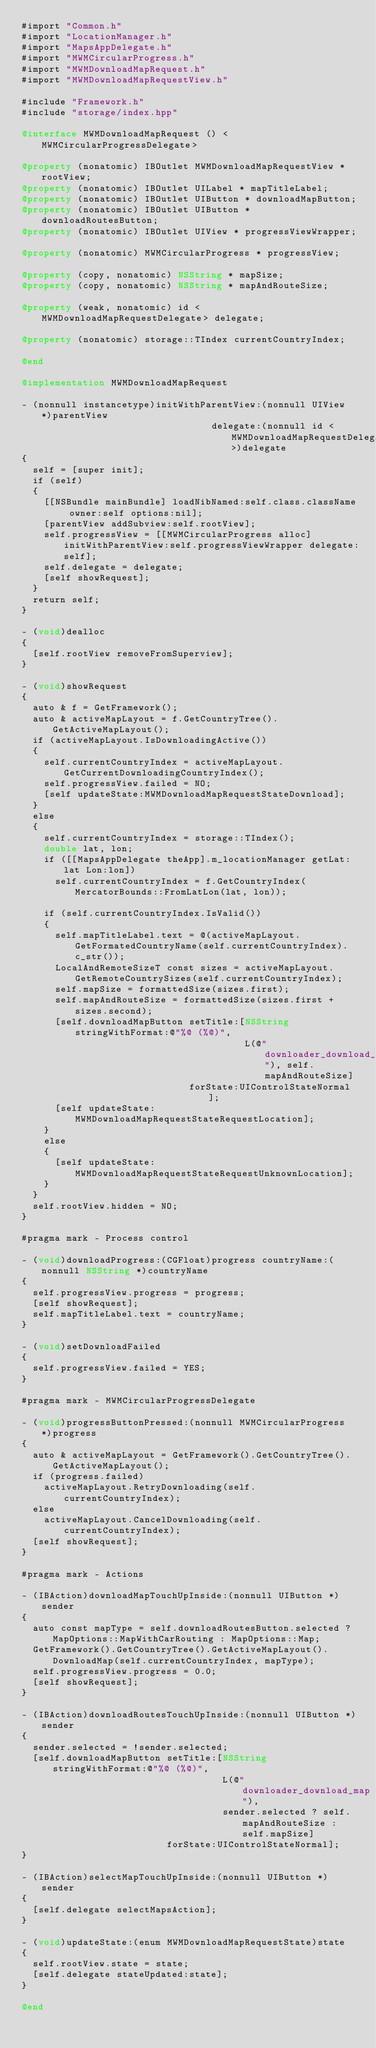<code> <loc_0><loc_0><loc_500><loc_500><_ObjectiveC_>#import "Common.h"
#import "LocationManager.h"
#import "MapsAppDelegate.h"
#import "MWMCircularProgress.h"
#import "MWMDownloadMapRequest.h"
#import "MWMDownloadMapRequestView.h"

#include "Framework.h"
#include "storage/index.hpp"

@interface MWMDownloadMapRequest () <MWMCircularProgressDelegate>

@property (nonatomic) IBOutlet MWMDownloadMapRequestView * rootView;
@property (nonatomic) IBOutlet UILabel * mapTitleLabel;
@property (nonatomic) IBOutlet UIButton * downloadMapButton;
@property (nonatomic) IBOutlet UIButton * downloadRoutesButton;
@property (nonatomic) IBOutlet UIView * progressViewWrapper;

@property (nonatomic) MWMCircularProgress * progressView;

@property (copy, nonatomic) NSString * mapSize;
@property (copy, nonatomic) NSString * mapAndRouteSize;

@property (weak, nonatomic) id <MWMDownloadMapRequestDelegate> delegate;

@property (nonatomic) storage::TIndex currentCountryIndex;

@end

@implementation MWMDownloadMapRequest

- (nonnull instancetype)initWithParentView:(nonnull UIView *)parentView
                                  delegate:(nonnull id <MWMDownloadMapRequestDelegate>)delegate
{
  self = [super init];
  if (self)
  {
    [[NSBundle mainBundle] loadNibNamed:self.class.className owner:self options:nil];
    [parentView addSubview:self.rootView];
    self.progressView = [[MWMCircularProgress alloc] initWithParentView:self.progressViewWrapper delegate:self];
    self.delegate = delegate;
    [self showRequest];
  }
  return self;
}

- (void)dealloc
{
  [self.rootView removeFromSuperview];
}

- (void)showRequest
{
  auto & f = GetFramework();
  auto & activeMapLayout = f.GetCountryTree().GetActiveMapLayout();
  if (activeMapLayout.IsDownloadingActive())
  {
    self.currentCountryIndex = activeMapLayout.GetCurrentDownloadingCountryIndex();
    self.progressView.failed = NO;
    [self updateState:MWMDownloadMapRequestStateDownload];
  }
  else
  {
    self.currentCountryIndex = storage::TIndex();
    double lat, lon;
    if ([[MapsAppDelegate theApp].m_locationManager getLat:lat Lon:lon])
      self.currentCountryIndex = f.GetCountryIndex(MercatorBounds::FromLatLon(lat, lon));

    if (self.currentCountryIndex.IsValid())
    {
      self.mapTitleLabel.text = @(activeMapLayout.GetFormatedCountryName(self.currentCountryIndex).c_str());
      LocalAndRemoteSizeT const sizes = activeMapLayout.GetRemoteCountrySizes(self.currentCountryIndex);
      self.mapSize = formattedSize(sizes.first);
      self.mapAndRouteSize = formattedSize(sizes.first + sizes.second);
      [self.downloadMapButton setTitle:[NSString stringWithFormat:@"%@ (%@)",
                                        L(@"downloader_download_map"), self.mapAndRouteSize]
                              forState:UIControlStateNormal];
      [self updateState:MWMDownloadMapRequestStateRequestLocation];
    }
    else
    {
      [self updateState:MWMDownloadMapRequestStateRequestUnknownLocation];
    }
  }
  self.rootView.hidden = NO;
}

#pragma mark - Process control

- (void)downloadProgress:(CGFloat)progress countryName:(nonnull NSString *)countryName
{
  self.progressView.progress = progress;
  [self showRequest];
  self.mapTitleLabel.text = countryName;
}

- (void)setDownloadFailed
{
  self.progressView.failed = YES;
}

#pragma mark - MWMCircularProgressDelegate

- (void)progressButtonPressed:(nonnull MWMCircularProgress *)progress
{
  auto & activeMapLayout = GetFramework().GetCountryTree().GetActiveMapLayout();
  if (progress.failed)
    activeMapLayout.RetryDownloading(self.currentCountryIndex);
  else
    activeMapLayout.CancelDownloading(self.currentCountryIndex);
  [self showRequest];
}

#pragma mark - Actions

- (IBAction)downloadMapTouchUpInside:(nonnull UIButton *)sender
{
  auto const mapType = self.downloadRoutesButton.selected ? MapOptions::MapWithCarRouting : MapOptions::Map;
  GetFramework().GetCountryTree().GetActiveMapLayout().DownloadMap(self.currentCountryIndex, mapType);
  self.progressView.progress = 0.0;
  [self showRequest];
}

- (IBAction)downloadRoutesTouchUpInside:(nonnull UIButton *)sender
{
  sender.selected = !sender.selected;
  [self.downloadMapButton setTitle:[NSString stringWithFormat:@"%@ (%@)",
                                    L(@"downloader_download_map"),
                                    sender.selected ? self.mapAndRouteSize : self.mapSize]
                          forState:UIControlStateNormal];
}

- (IBAction)selectMapTouchUpInside:(nonnull UIButton *)sender
{
  [self.delegate selectMapsAction];
}

- (void)updateState:(enum MWMDownloadMapRequestState)state
{
  self.rootView.state = state;
  [self.delegate stateUpdated:state];
}

@end
</code> 